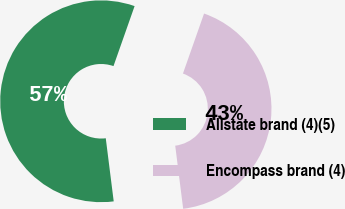<chart> <loc_0><loc_0><loc_500><loc_500><pie_chart><fcel>Allstate brand (4)(5)<fcel>Encompass brand (4)<nl><fcel>57.38%<fcel>42.62%<nl></chart> 